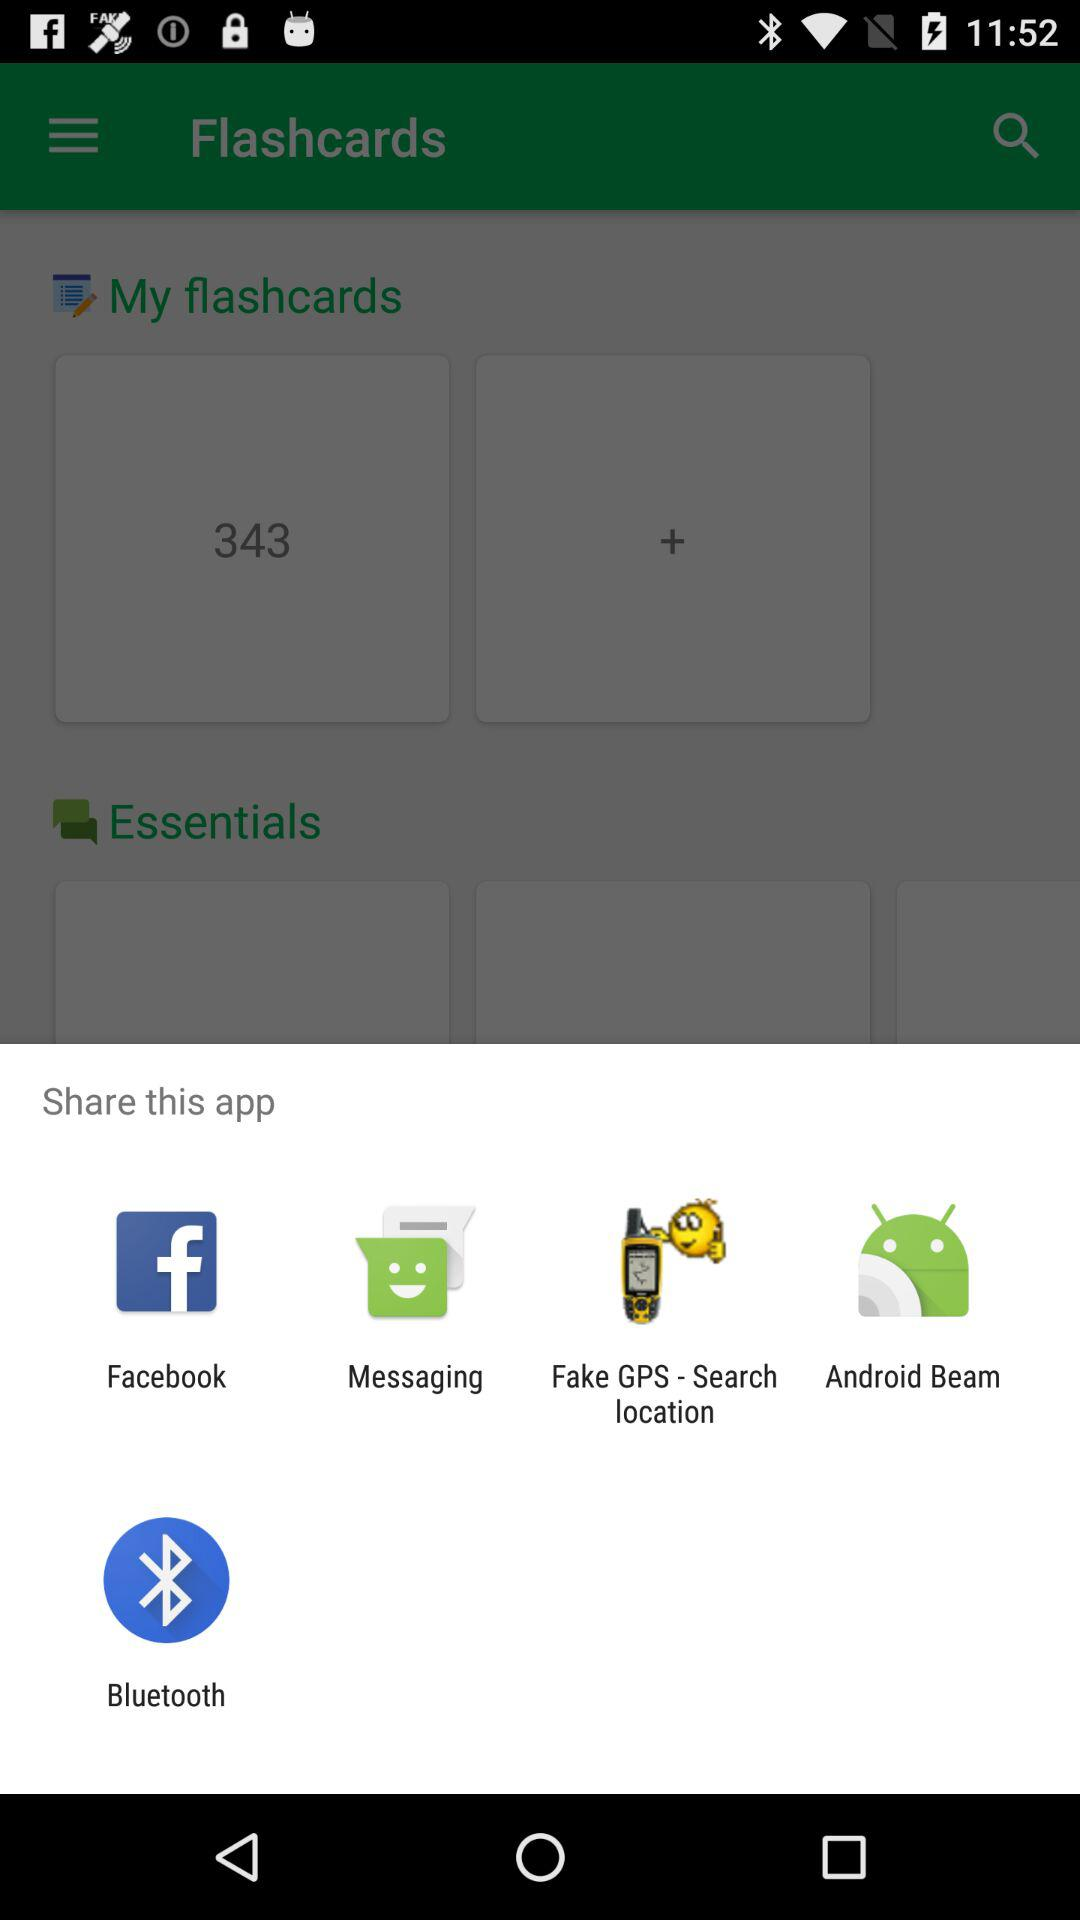Which application can I use to share the app? You can use "Facebook", "Messaging", "Fake GPS - Search location", "Android Beam" and "Bluetooth" to share the app. 